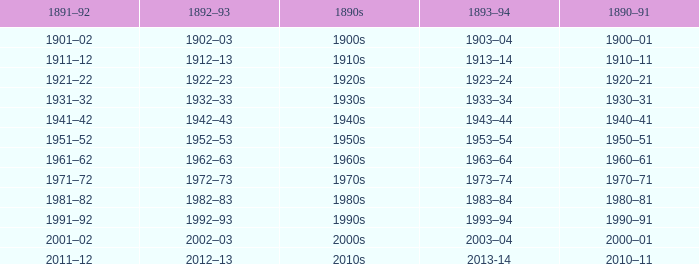What is the year from 1891-92 from the years 1890s to the 1960s? 1961–62. 